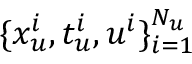<formula> <loc_0><loc_0><loc_500><loc_500>\{ x _ { u } ^ { i } , t _ { u } ^ { i } , u ^ { i } \} _ { i = 1 } ^ { N _ { u } }</formula> 